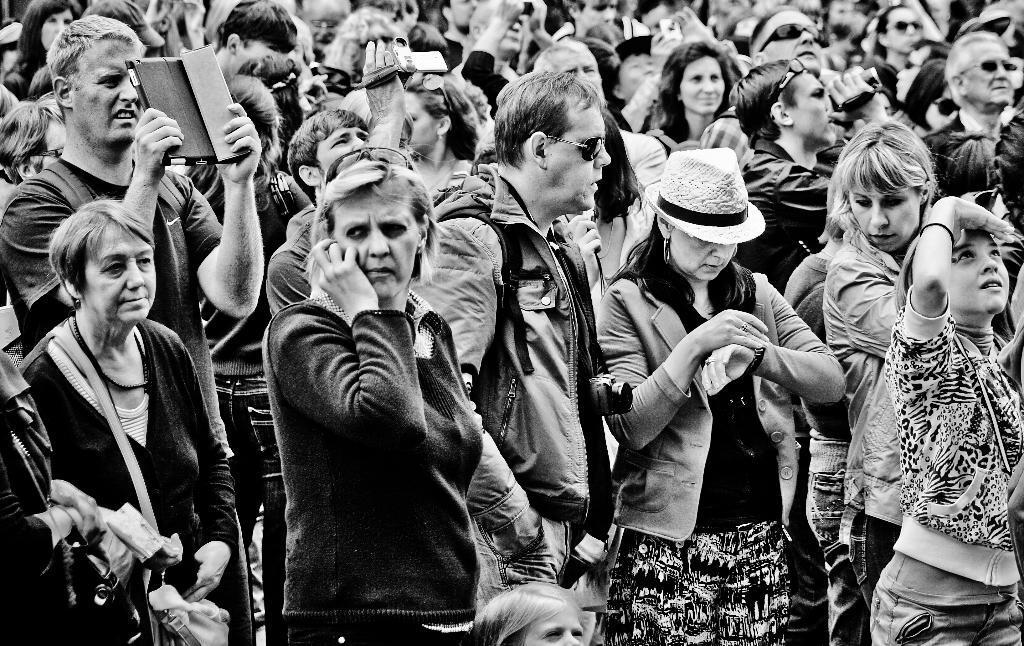Can you describe this image briefly? This is a black and white image. Here I can see many people standing. In the foreground a woman is looking into the watch. Another woman is speaking on the phone. A man is holding a device in the hands and looking into the device. 